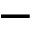<formula> <loc_0><loc_0><loc_500><loc_500>-</formula> 